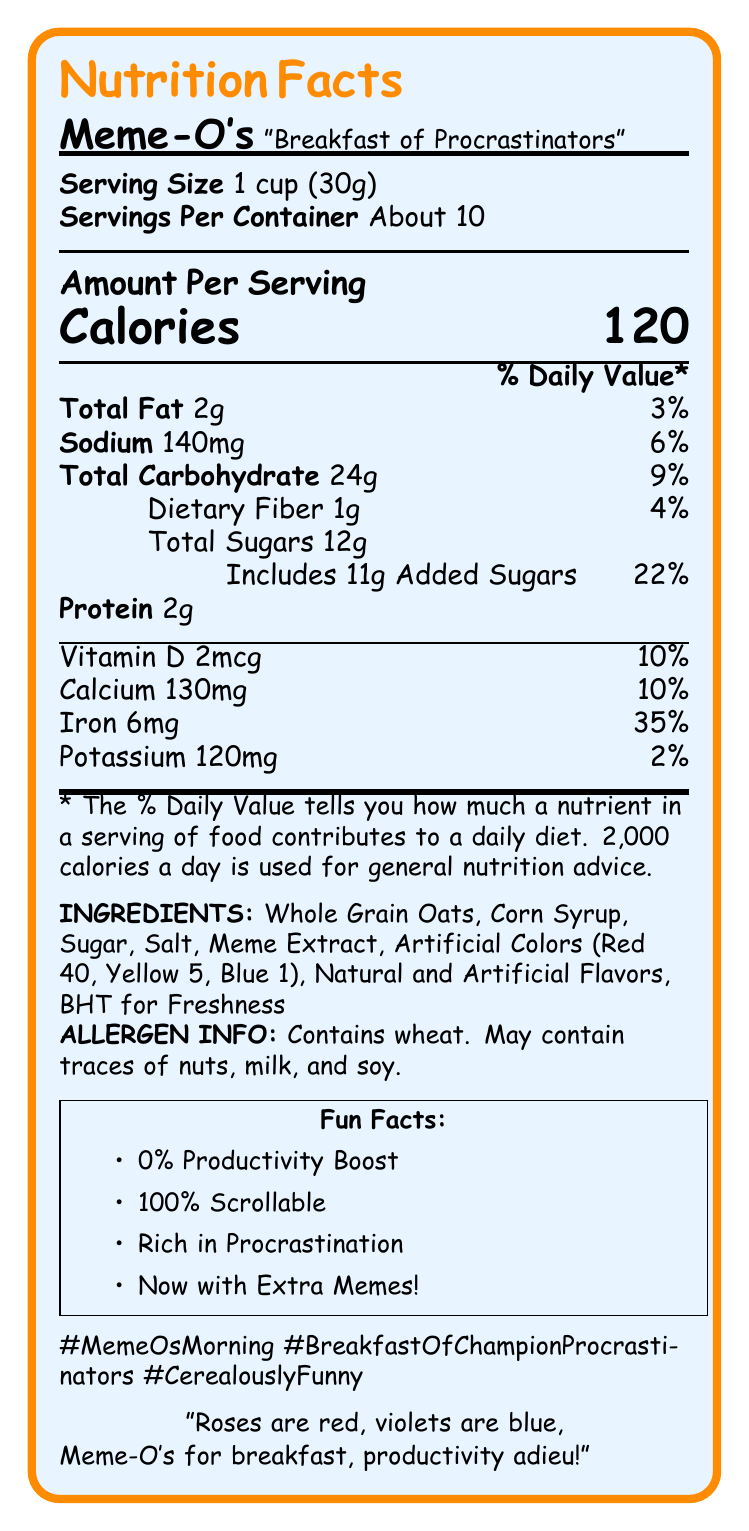what is the serving size of Meme-O's cereal? The document states the serving size as "1 cup (30g)".
Answer: 1 cup (30g) how many calories are in one serving of Meme-O's? The document mentions that each serving contains 120 calories.
Answer: 120 name one fun fact mentioned in the document about Meme-O's. The document lists several fun facts including "0% Productivity Boost".
Answer: 0% Productivity Boost what is the daily value percentage of iron per serving? The document shows that the serving contains 35% of the daily value for iron.
Answer: 35% how many grams of total fat does one serving of Meme-O's have? The document lists the total fat amount as 2g.
Answer: 2g how many milligrams of sodium are in one serving? A. 100mg B. 140mg C. 160mg D. 190mg The document clearly states the sodium content as 140mg per serving.
Answer: B. 140mg which ingredient is included for freshness? A. Whole Grain Oats B. Corn Syrup C. BHT D. Meme Extract The document lists BHT for freshness among the ingredients.
Answer: C. BHT does Meme-O's contain any wheat? The allergen info section of the document specifies that Meme-O's contains wheat.
Answer: Yes summarize the main idea of the document. The main idea of the document is to inform the reader about the nutritional content and ingredients of Meme-O's cereal in a fun and engaging way.
Answer: The document provides the nutrition facts and other information about Meme-O's cereal, including serving sizes, calorie content, nutrients, ingredients, allergen info, fun facts, hashtags, and a humorous poem snippet. how many servings are approximately in one container of Meme-O's? The document mentions that there are about 10 servings per container.
Answer: About 10 what vitamin has a daily value percentage of 10% per serving in the Meme-O's? The document lists Vitamin D at 10% of the daily value per serving.
Answer: Vitamin D how much of the daily value of calcium does one serving of Meme-O's provide? A. 2% B. 10% C. 20% D. 25% The document states that one serving of Meme-O's provides 10% of the daily value for calcium.
Answer: B. 10% is the document presented in a traditional or humorous tone? The document includes witty catchphrases, a fun poem snippet, and amusing fun facts indicating a humorous tone.
Answer: Humorous how many grams of dietary fiber are in one serving? The document lists the dietary fiber content as 1g per serving.
Answer: 1g what are the social media hashtags included in the document? The document provides three hashtags for social media use: #MemeOsMorning, #BreakfastOfChampionProcrastinators, and #CerealouslyFunny.
Answer: #MemeOsMorning, #BreakfastOfChampionProcrastinators, #CerealouslyFunny does Meme-O's cereal contain any milk? The allergen info mentions that it may contain traces of nuts, milk, and soy, but does not confirm the presence of milk as a primary ingredient.
Answer: Not enough information how many grams of added sugars are there in one serving of Meme-O's? The document specifies that there are 11 grams of added sugars in one serving.
Answer: 11g 